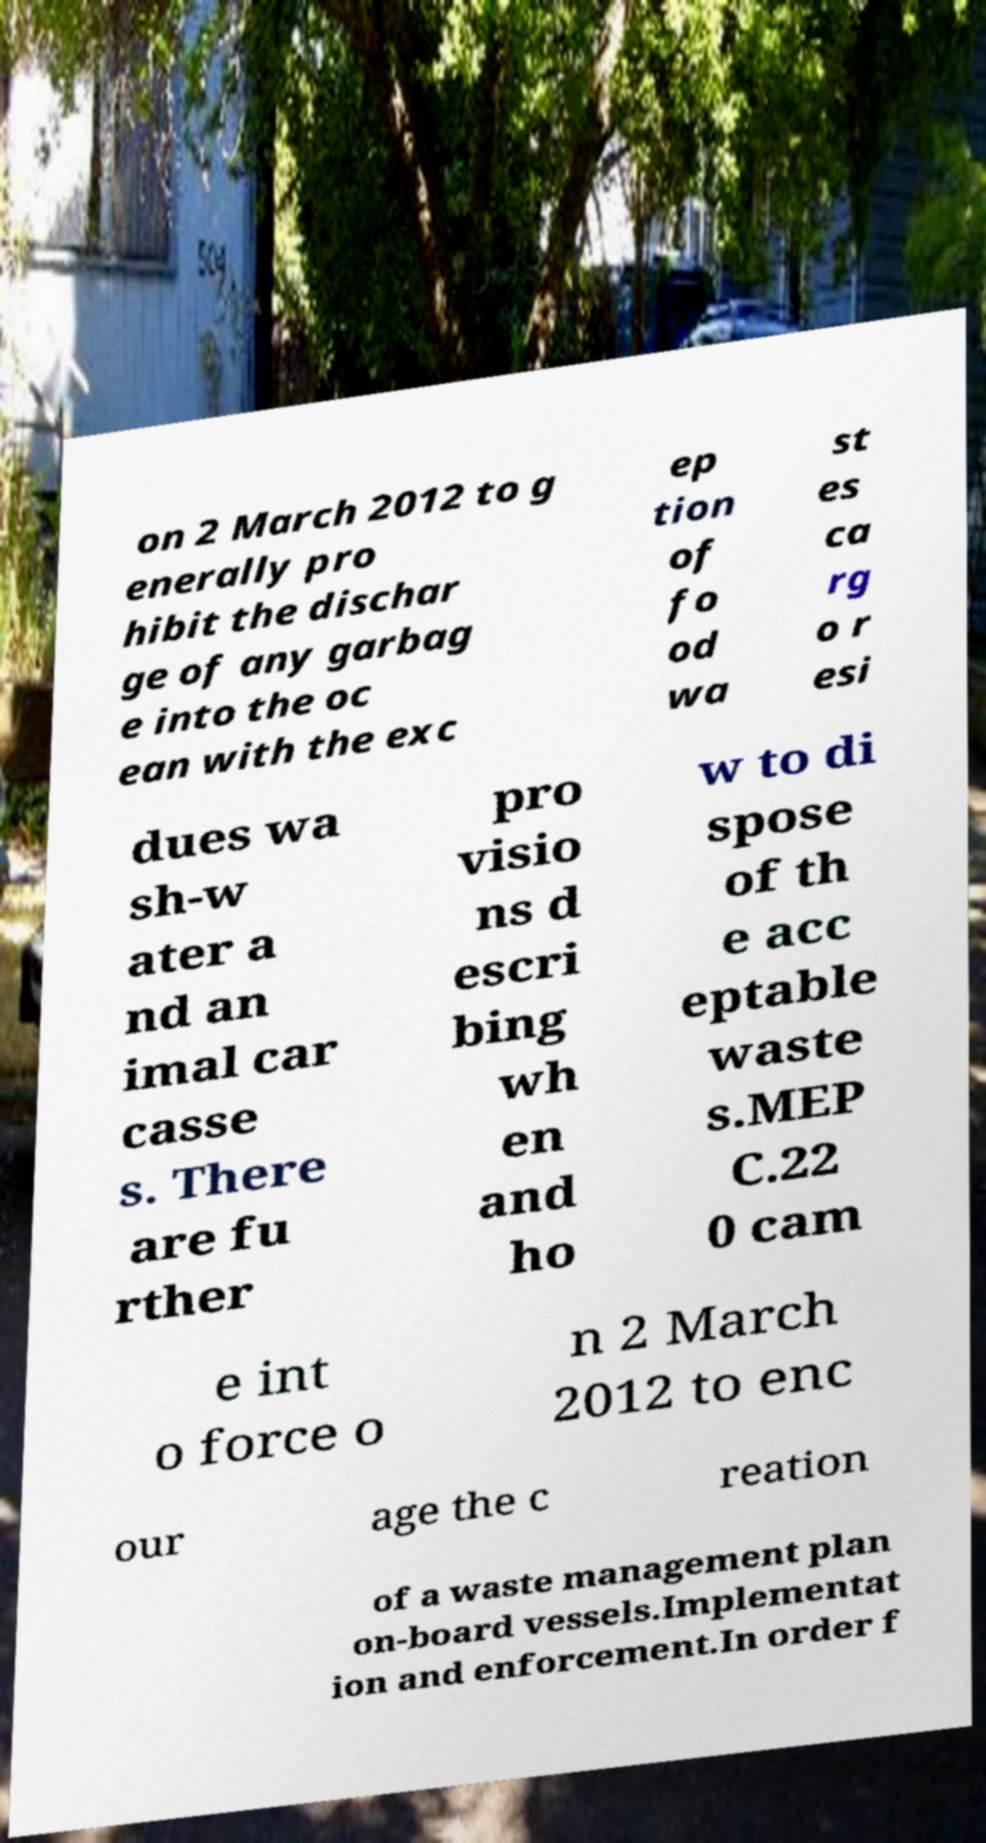Can you accurately transcribe the text from the provided image for me? on 2 March 2012 to g enerally pro hibit the dischar ge of any garbag e into the oc ean with the exc ep tion of fo od wa st es ca rg o r esi dues wa sh-w ater a nd an imal car casse s. There are fu rther pro visio ns d escri bing wh en and ho w to di spose of th e acc eptable waste s.MEP C.22 0 cam e int o force o n 2 March 2012 to enc our age the c reation of a waste management plan on-board vessels.Implementat ion and enforcement.In order f 